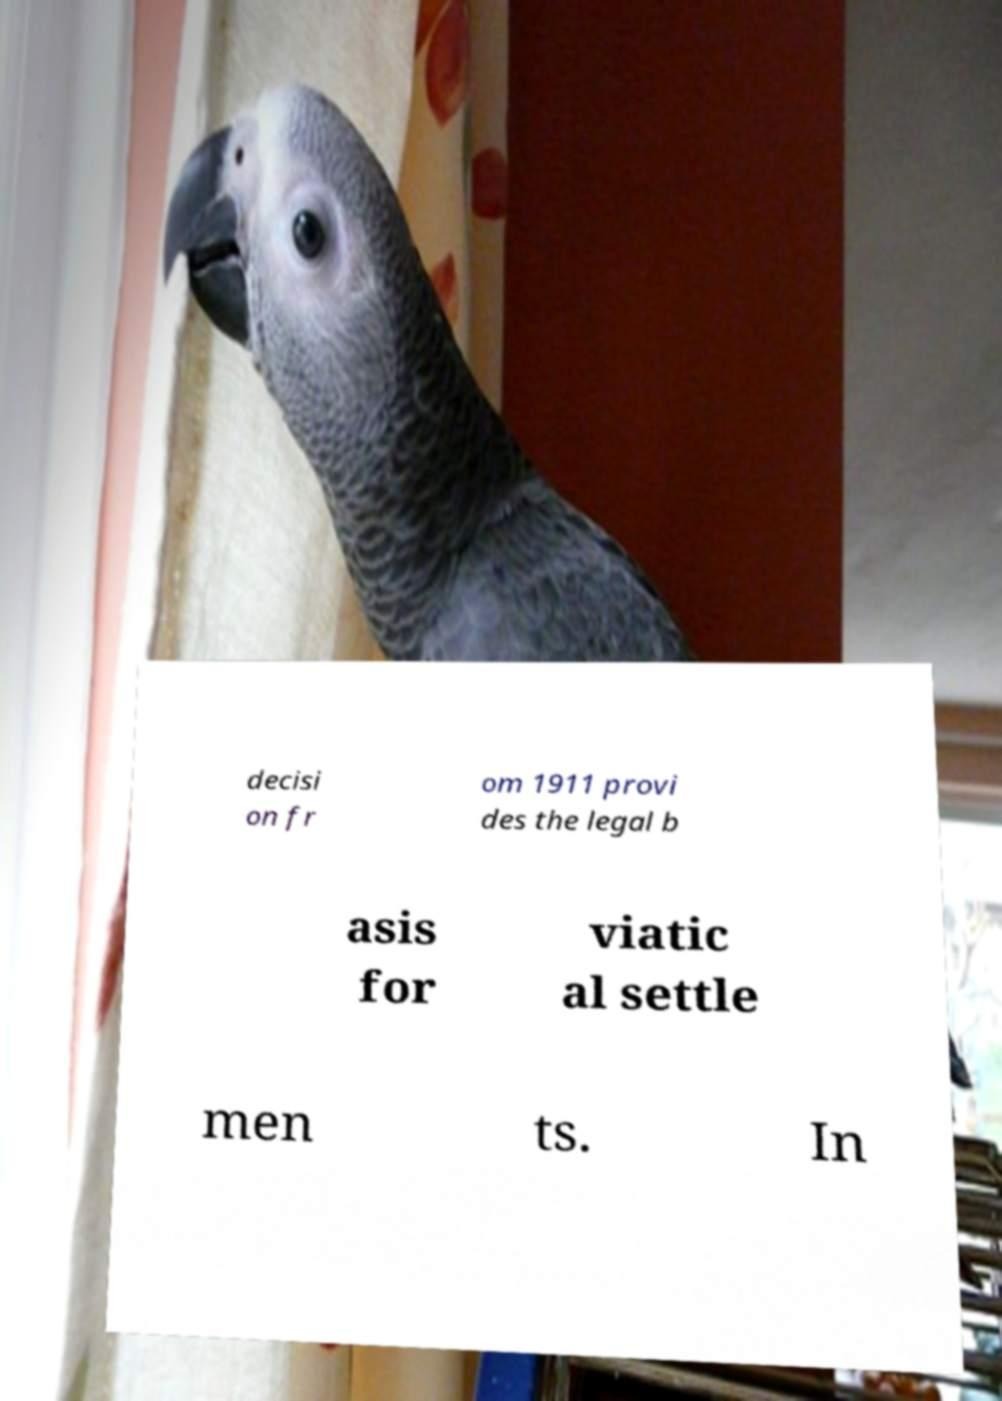What messages or text are displayed in this image? I need them in a readable, typed format. decisi on fr om 1911 provi des the legal b asis for viatic al settle men ts. In 